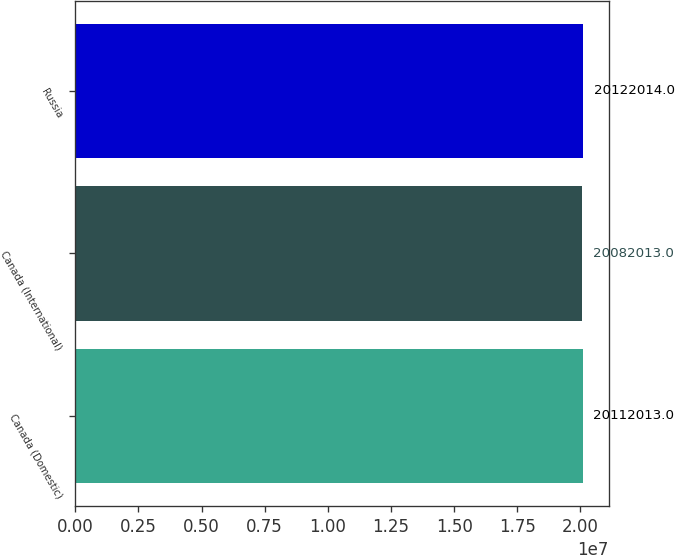Convert chart to OTSL. <chart><loc_0><loc_0><loc_500><loc_500><bar_chart><fcel>Canada (Domestic)<fcel>Canada (International)<fcel>Russia<nl><fcel>2.0112e+07<fcel>2.0082e+07<fcel>2.0122e+07<nl></chart> 